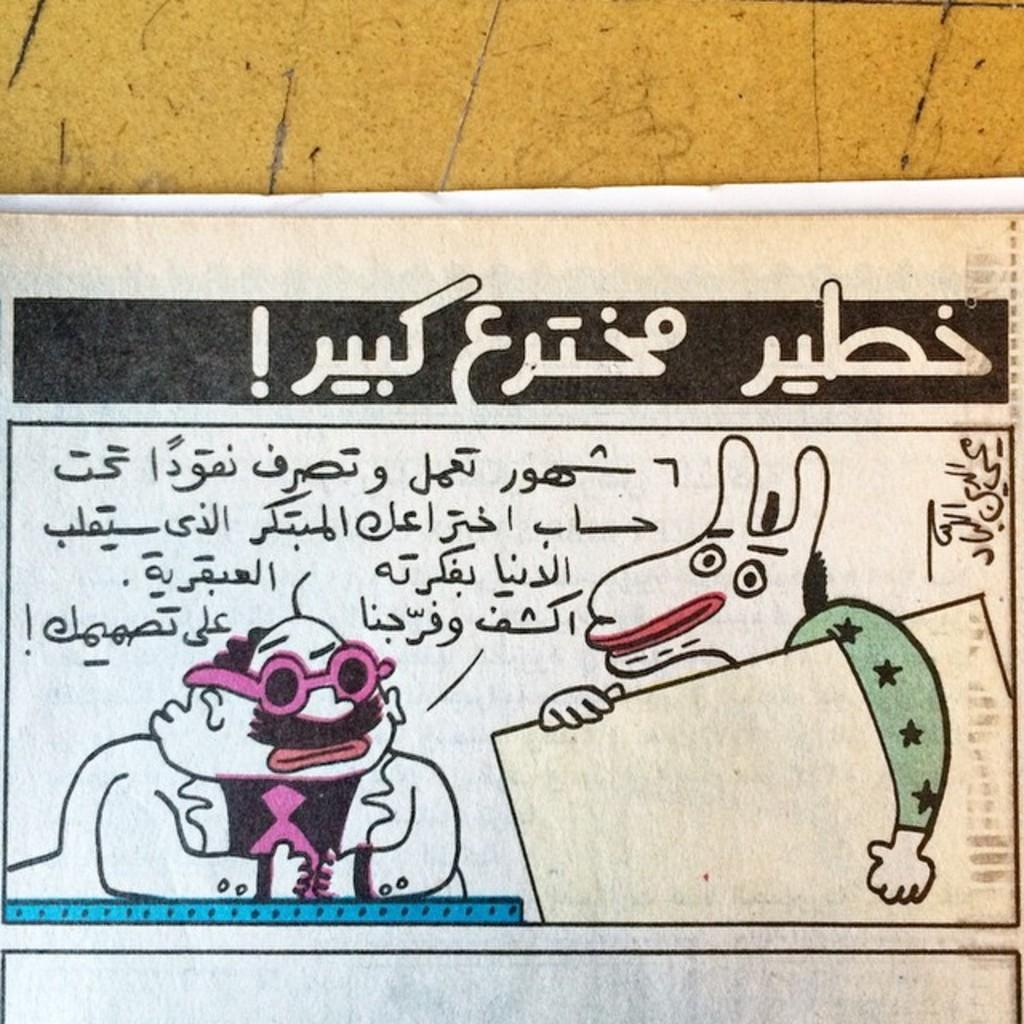What is the main object in the image? There is a white color board in the image. What is the color board placed on? The board is on a wooden surface. What can be seen on the color board? There is text and cartoon images on the board. What type of snail can be seen crawling on the color board in the image? There is no snail present on the color board in the image. What sound does the owl make while sitting on the wooden surface in the image? There is no owl present in the image, so it cannot make any sound. 